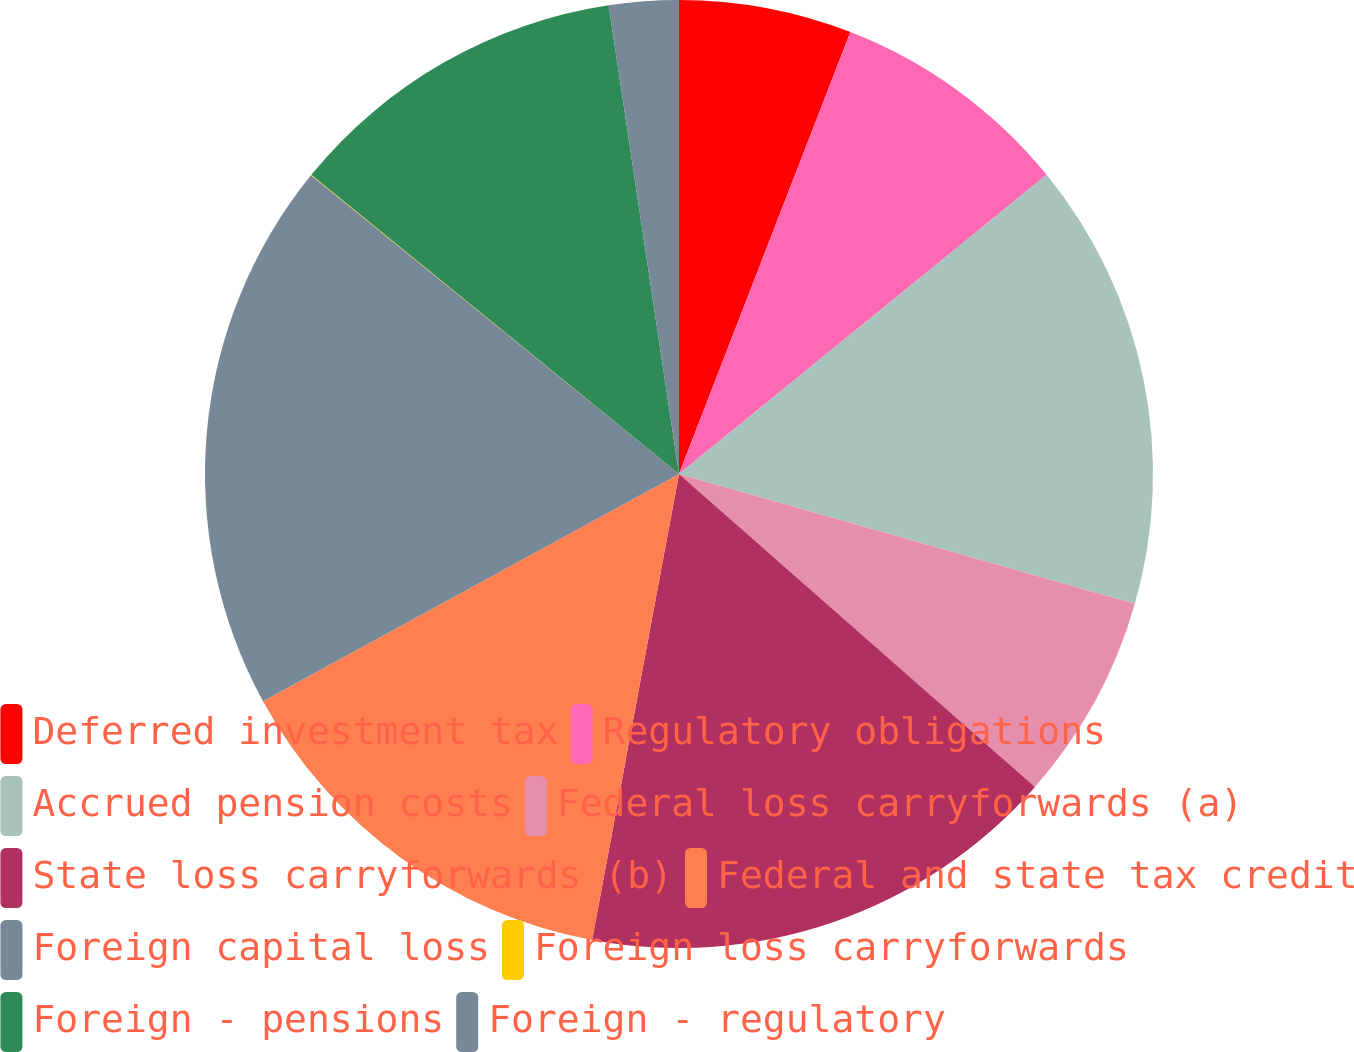Convert chart. <chart><loc_0><loc_0><loc_500><loc_500><pie_chart><fcel>Deferred investment tax<fcel>Regulatory obligations<fcel>Accrued pension costs<fcel>Federal loss carryforwards (a)<fcel>State loss carryforwards (b)<fcel>Federal and state tax credit<fcel>Foreign capital loss<fcel>Foreign loss carryforwards<fcel>Foreign - pensions<fcel>Foreign - regulatory<nl><fcel>5.89%<fcel>8.24%<fcel>15.29%<fcel>7.06%<fcel>16.46%<fcel>14.11%<fcel>18.81%<fcel>0.02%<fcel>11.76%<fcel>2.37%<nl></chart> 